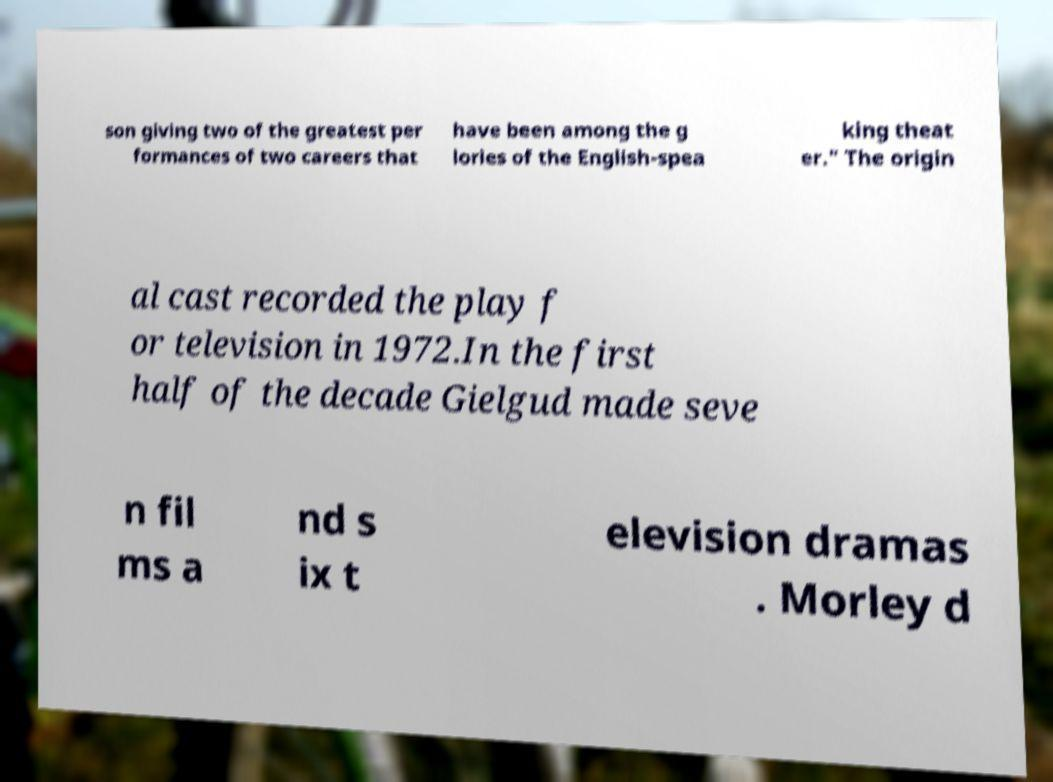Can you accurately transcribe the text from the provided image for me? son giving two of the greatest per formances of two careers that have been among the g lories of the English-spea king theat er." The origin al cast recorded the play f or television in 1972.In the first half of the decade Gielgud made seve n fil ms a nd s ix t elevision dramas . Morley d 